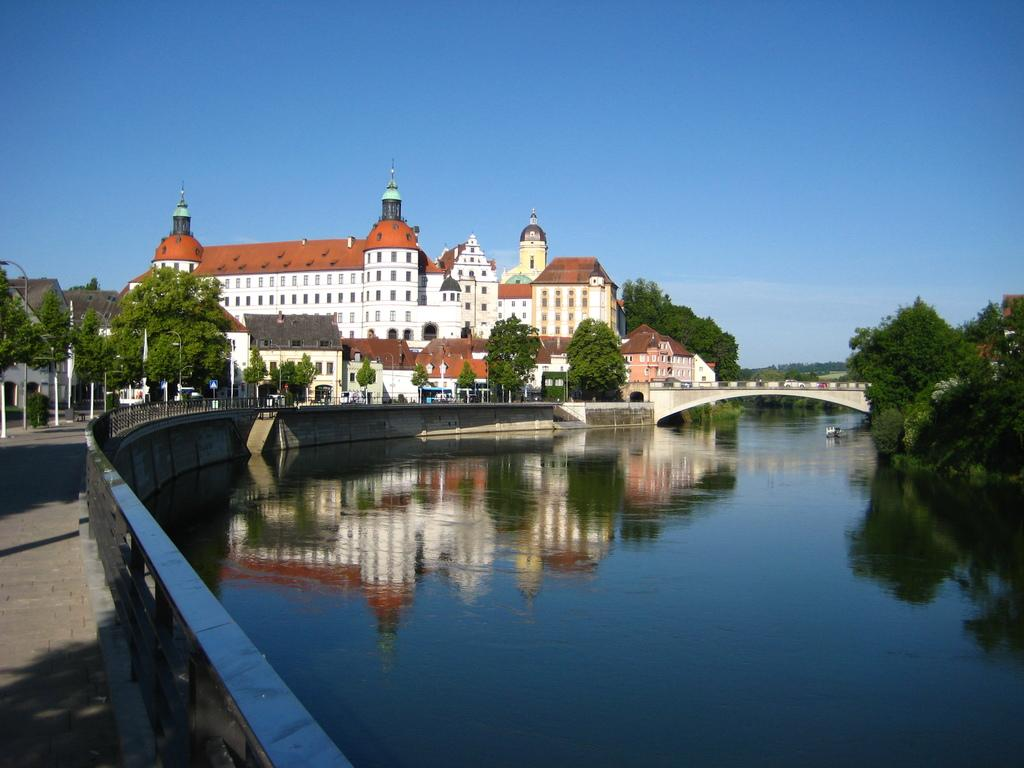What can be seen on the right side of the image? There is water visible on the right side of the image. What is visible in the background of the image? There are trees, houses, and clouds in the sky in the background of the image. How many oranges are hanging from the trees in the image? There are no oranges visible in the image; only trees, houses, and clouds can be seen in the background. What type of thread is being used to hold the clouds in the sky? There is no thread present in the image; the clouds are naturally suspended in the sky. 